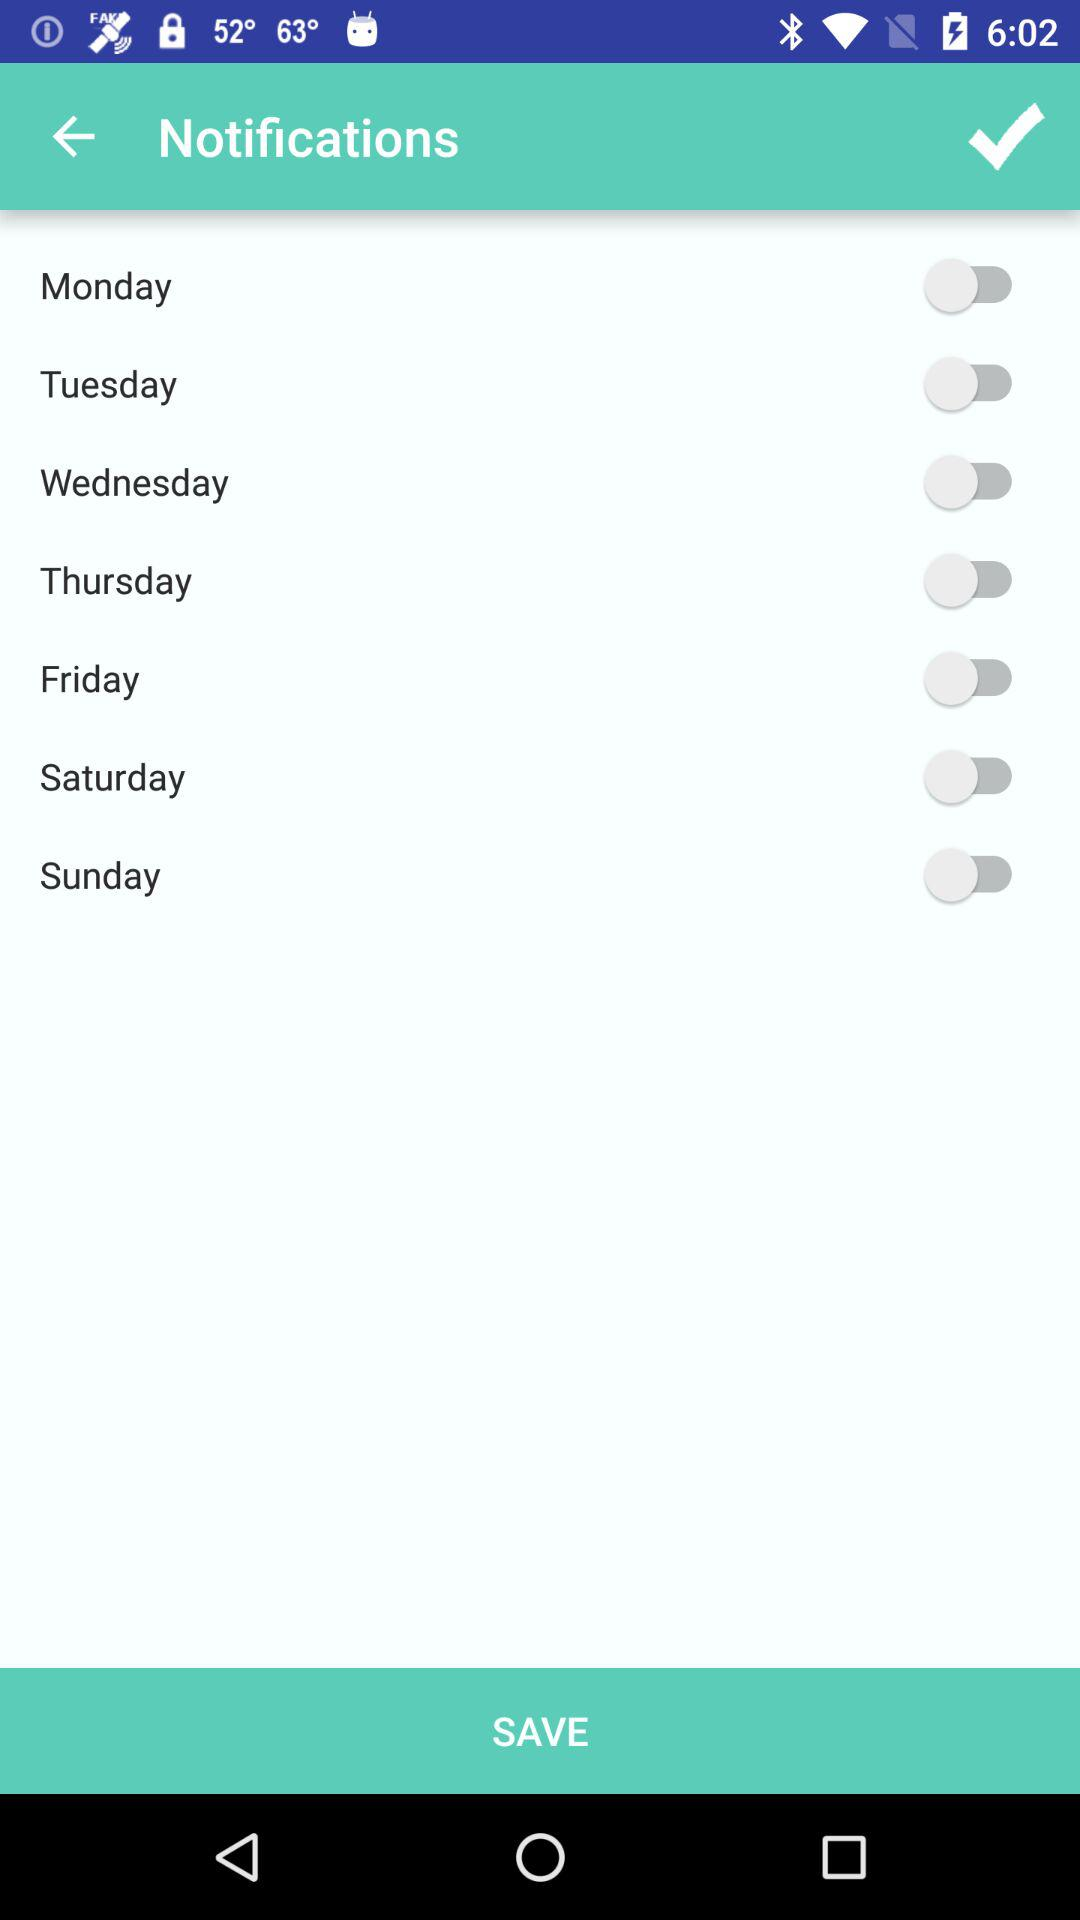What is the current status of "Friday"? The status is "off". 